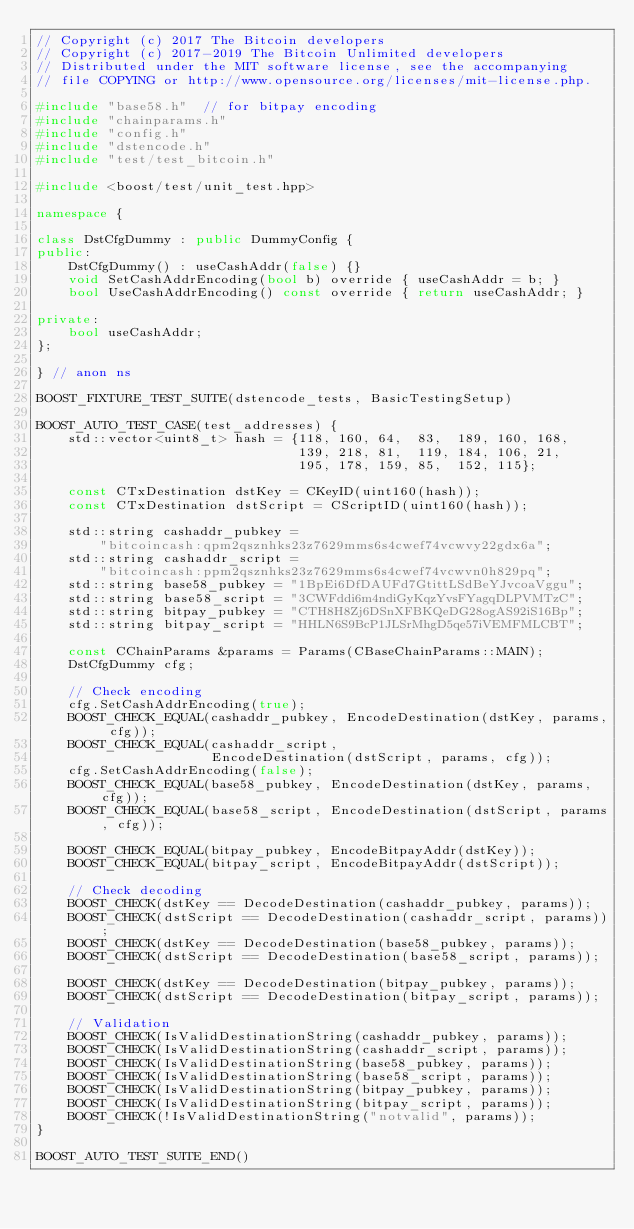Convert code to text. <code><loc_0><loc_0><loc_500><loc_500><_C++_>// Copyright (c) 2017 The Bitcoin developers
// Copyright (c) 2017-2019 The Bitcoin Unlimited developers
// Distributed under the MIT software license, see the accompanying
// file COPYING or http://www.opensource.org/licenses/mit-license.php.

#include "base58.h"  // for bitpay encoding
#include "chainparams.h"
#include "config.h"
#include "dstencode.h"
#include "test/test_bitcoin.h"

#include <boost/test/unit_test.hpp>

namespace {

class DstCfgDummy : public DummyConfig {
public:
    DstCfgDummy() : useCashAddr(false) {}
    void SetCashAddrEncoding(bool b) override { useCashAddr = b; }
    bool UseCashAddrEncoding() const override { return useCashAddr; }

private:
    bool useCashAddr;
};

} // anon ns

BOOST_FIXTURE_TEST_SUITE(dstencode_tests, BasicTestingSetup)

BOOST_AUTO_TEST_CASE(test_addresses) {
    std::vector<uint8_t> hash = {118, 160, 64,  83,  189, 160, 168,
                                 139, 218, 81,  119, 184, 106, 21,
                                 195, 178, 159, 85,  152, 115};

    const CTxDestination dstKey = CKeyID(uint160(hash));
    const CTxDestination dstScript = CScriptID(uint160(hash));

    std::string cashaddr_pubkey =
        "bitcoincash:qpm2qsznhks23z7629mms6s4cwef74vcwvy22gdx6a";
    std::string cashaddr_script =
        "bitcoincash:ppm2qsznhks23z7629mms6s4cwef74vcwvn0h829pq";
    std::string base58_pubkey = "1BpEi6DfDAUFd7GtittLSdBeYJvcoaVggu";
    std::string base58_script = "3CWFddi6m4ndiGyKqzYvsFYagqDLPVMTzC";
    std::string bitpay_pubkey = "CTH8H8Zj6DSnXFBKQeDG28ogAS92iS16Bp";
    std::string bitpay_script = "HHLN6S9BcP1JLSrMhgD5qe57iVEMFMLCBT";

    const CChainParams &params = Params(CBaseChainParams::MAIN);
    DstCfgDummy cfg;

    // Check encoding
    cfg.SetCashAddrEncoding(true);
    BOOST_CHECK_EQUAL(cashaddr_pubkey, EncodeDestination(dstKey, params, cfg));
    BOOST_CHECK_EQUAL(cashaddr_script,
                      EncodeDestination(dstScript, params, cfg));
    cfg.SetCashAddrEncoding(false);
    BOOST_CHECK_EQUAL(base58_pubkey, EncodeDestination(dstKey, params, cfg));
    BOOST_CHECK_EQUAL(base58_script, EncodeDestination(dstScript, params, cfg));

    BOOST_CHECK_EQUAL(bitpay_pubkey, EncodeBitpayAddr(dstKey));
    BOOST_CHECK_EQUAL(bitpay_script, EncodeBitpayAddr(dstScript));

    // Check decoding
    BOOST_CHECK(dstKey == DecodeDestination(cashaddr_pubkey, params));
    BOOST_CHECK(dstScript == DecodeDestination(cashaddr_script, params));
    BOOST_CHECK(dstKey == DecodeDestination(base58_pubkey, params));
    BOOST_CHECK(dstScript == DecodeDestination(base58_script, params));

    BOOST_CHECK(dstKey == DecodeDestination(bitpay_pubkey, params));
    BOOST_CHECK(dstScript == DecodeDestination(bitpay_script, params));

    // Validation
    BOOST_CHECK(IsValidDestinationString(cashaddr_pubkey, params));
    BOOST_CHECK(IsValidDestinationString(cashaddr_script, params));
    BOOST_CHECK(IsValidDestinationString(base58_pubkey, params));
    BOOST_CHECK(IsValidDestinationString(base58_script, params));
    BOOST_CHECK(IsValidDestinationString(bitpay_pubkey, params));
    BOOST_CHECK(IsValidDestinationString(bitpay_script, params));
    BOOST_CHECK(!IsValidDestinationString("notvalid", params));
}

BOOST_AUTO_TEST_SUITE_END()
</code> 